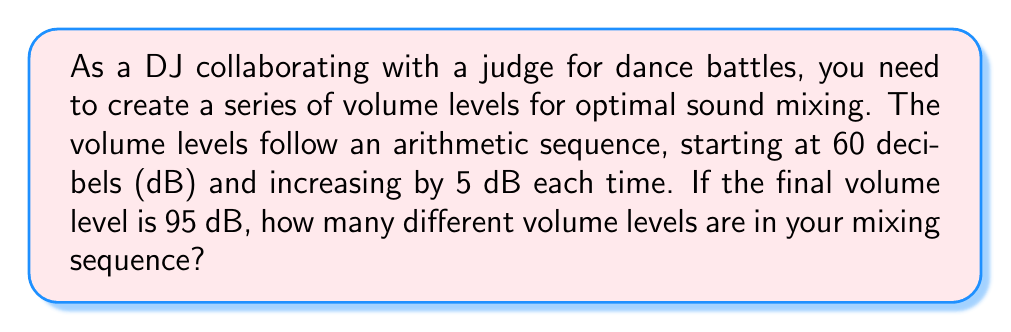What is the answer to this math problem? Let's approach this step-by-step using the arithmetic sequence formula:

1) In an arithmetic sequence, we have:
   $a_n = a_1 + (n-1)d$
   where $a_n$ is the nth term, $a_1$ is the first term, $n$ is the number of terms, and $d$ is the common difference.

2) We know:
   $a_1 = 60$ (first term)
   $d = 5$ (common difference)
   $a_n = 95$ (last term)

3) Let's substitute these into our formula:
   $95 = 60 + (n-1)5$

4) Now, let's solve for $n$:
   $95 - 60 = (n-1)5$
   $35 = (n-1)5$

5) Divide both sides by 5:
   $7 = n-1$

6) Add 1 to both sides:
   $8 = n$

Therefore, there are 8 terms in the sequence, which represents 8 different volume levels.
Answer: 8 